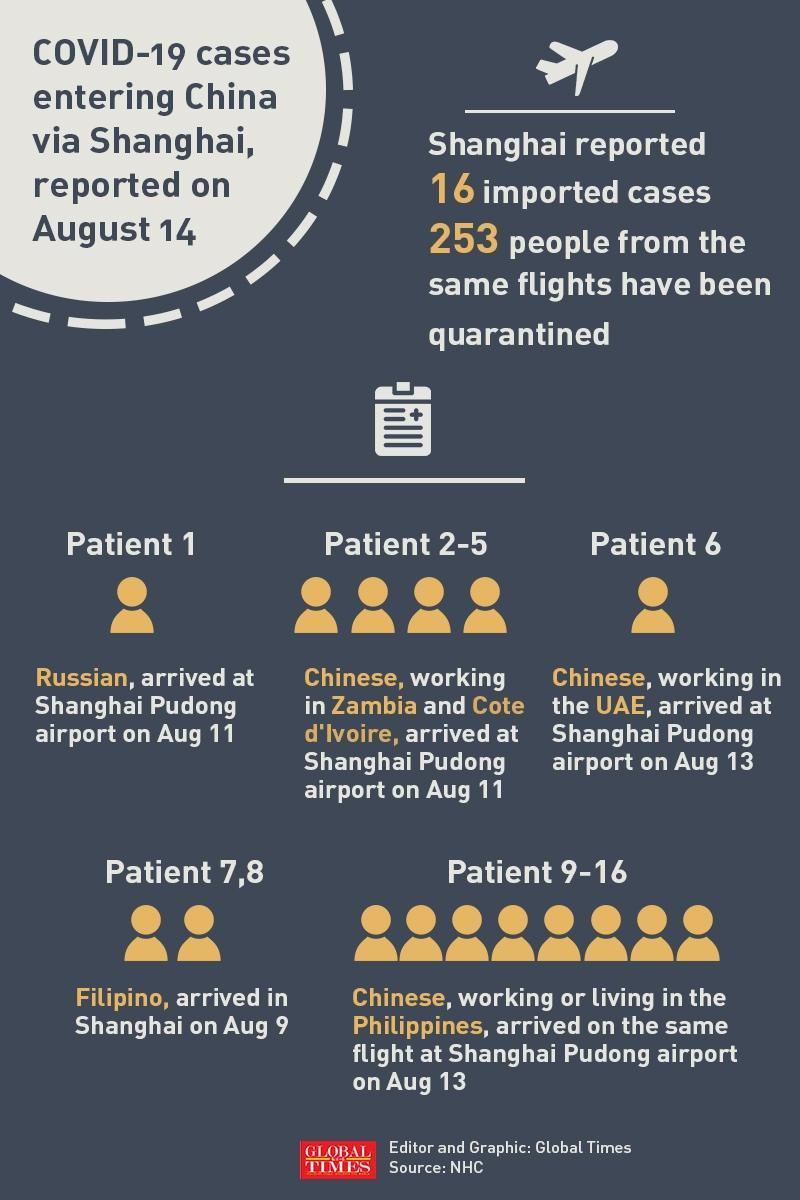Of the 16 imported cases in Shanghai, what was the nationality of the first patient?
Answer the question with a short phrase. Russian On which date did Patient 1 arrive? Aug 11 Which patients arrived on Aug 9? Patient 7,8 What was the nationality of Patient 7 & 8? Filipino Where was Patient no: 6 working? the UAE When did patients 2-5 arrive? Aug 11 